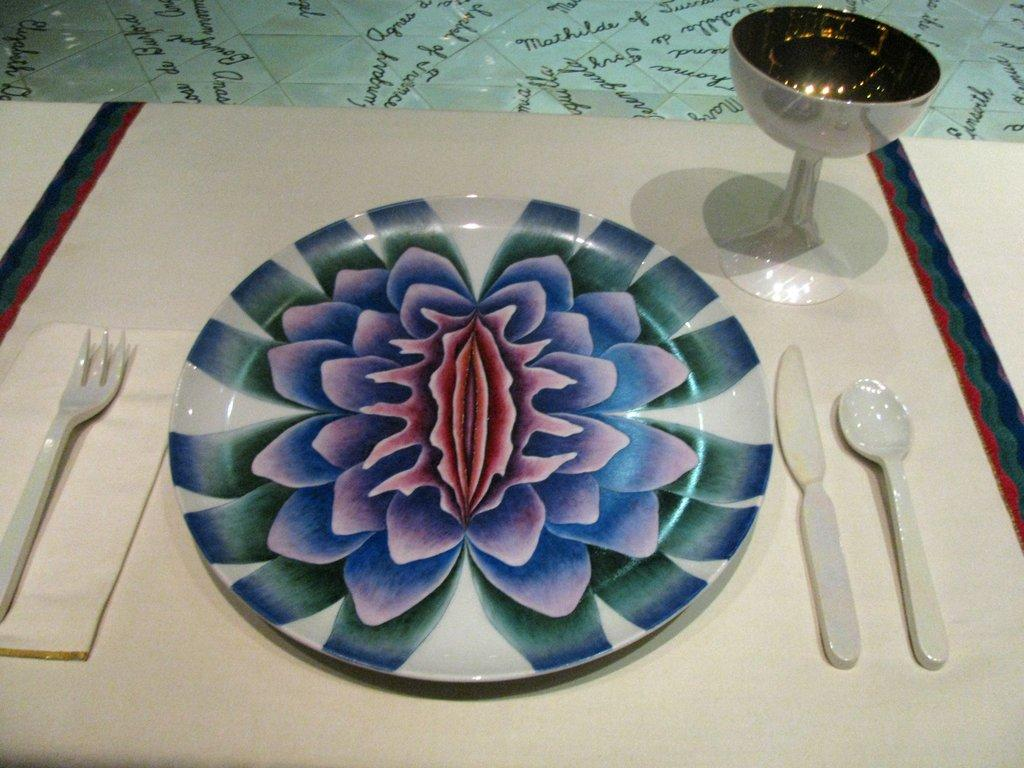What type of dishware is present in the image? There is a plate in the image. What utensils can be seen in the image? There is a spoon, a knife, and a fork in the image. What type of beverage container is present in the image? There is a glass in the image. What religious symbol is present in the image? There is no religious symbol present in the image. What type of carpenter tool can be seen in the image? There are no carpenter tools present in the image. 